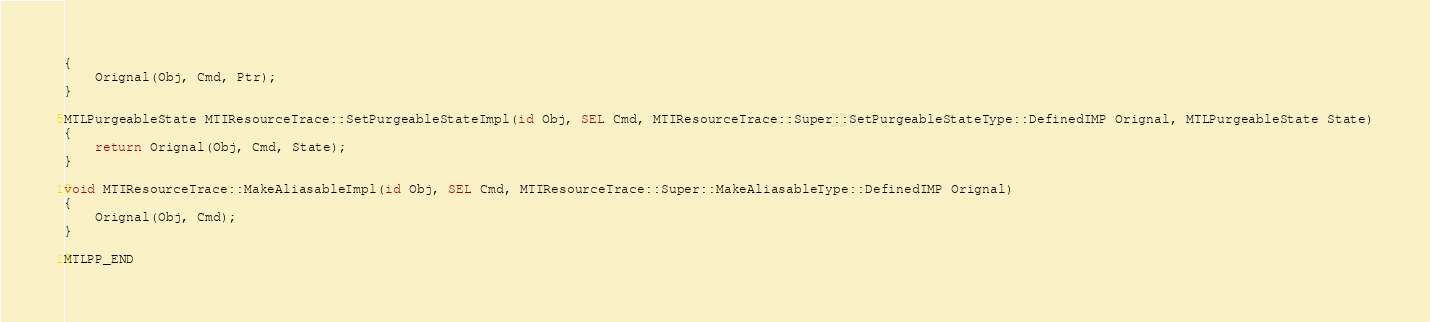<code> <loc_0><loc_0><loc_500><loc_500><_ObjectiveC_>{
	Orignal(Obj, Cmd, Ptr);
}

MTLPurgeableState MTIResourceTrace::SetPurgeableStateImpl(id Obj, SEL Cmd, MTIResourceTrace::Super::SetPurgeableStateType::DefinedIMP Orignal, MTLPurgeableState State)
{
	return Orignal(Obj, Cmd, State);
}

void MTIResourceTrace::MakeAliasableImpl(id Obj, SEL Cmd, MTIResourceTrace::Super::MakeAliasableType::DefinedIMP Orignal)
{
	Orignal(Obj, Cmd);
}

MTLPP_END

</code> 